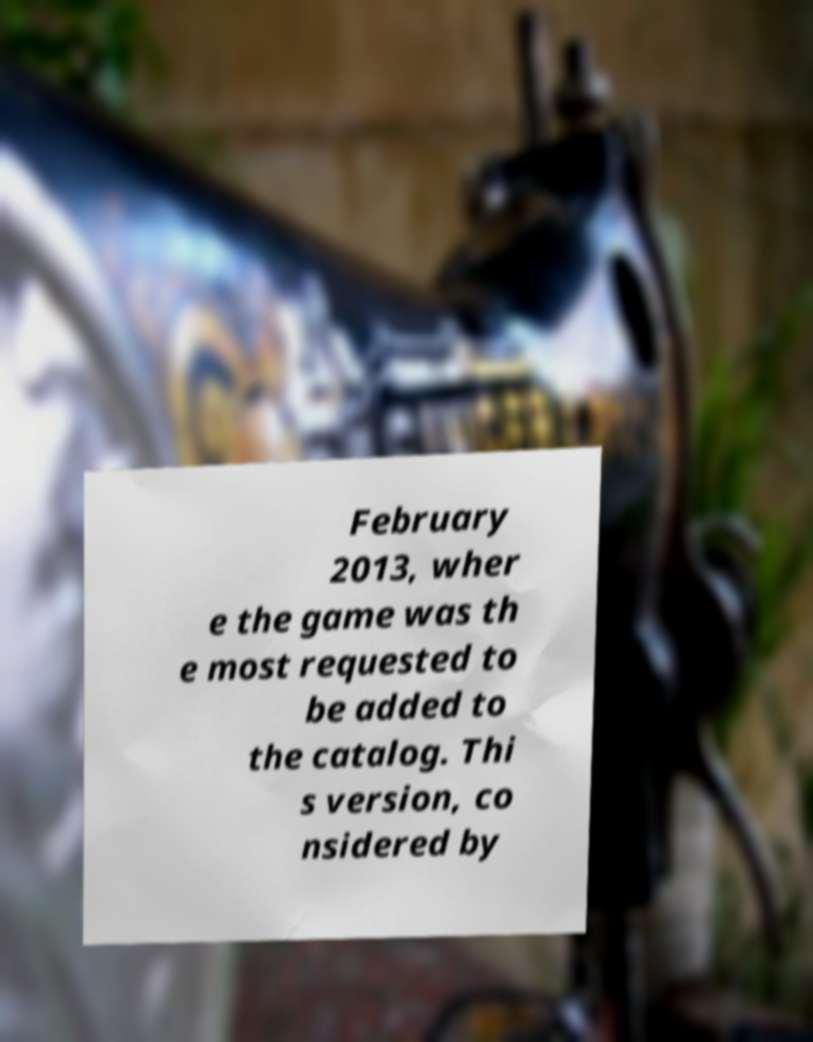Could you assist in decoding the text presented in this image and type it out clearly? February 2013, wher e the game was th e most requested to be added to the catalog. Thi s version, co nsidered by 